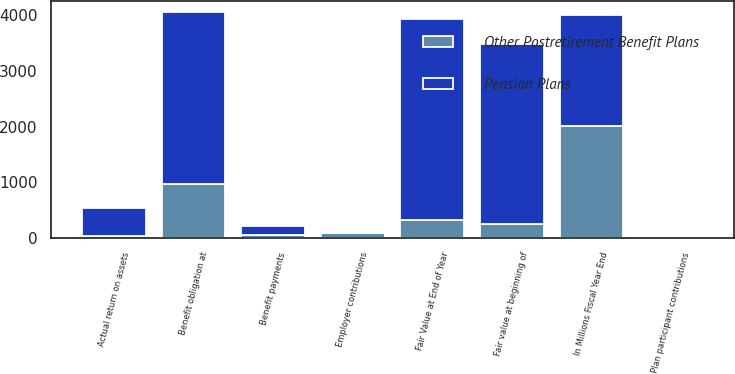Convert chart. <chart><loc_0><loc_0><loc_500><loc_500><stacked_bar_chart><ecel><fcel>In Millions Fiscal Year End<fcel>Fair value at beginning of<fcel>Actual return on assets<fcel>Employer contributions<fcel>Plan participant contributions<fcel>Benefit payments<fcel>Fair Value at End of Year<fcel>Benefit obligation at<nl><fcel>Pension Plans<fcel>2006<fcel>3237<fcel>502<fcel>8<fcel>1<fcel>154<fcel>3594<fcel>3082<nl><fcel>Other Postretirement Benefit Plans<fcel>2006<fcel>242<fcel>38<fcel>95<fcel>9<fcel>55<fcel>329<fcel>971<nl></chart> 